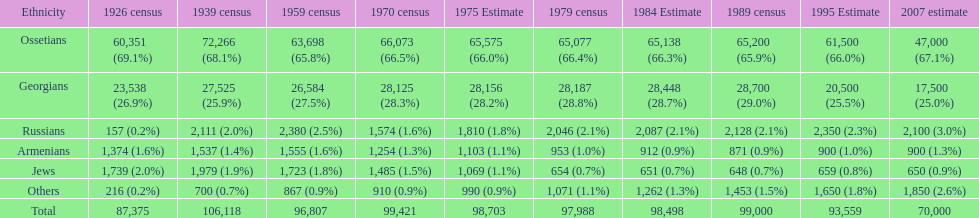Which population had the most people in 1926? Ossetians. 